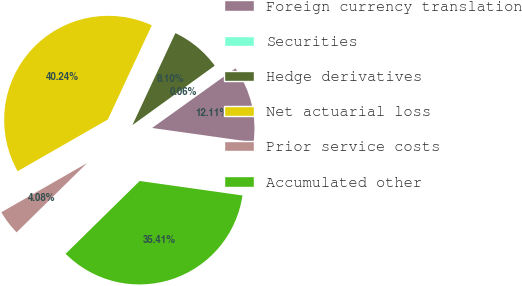Convert chart. <chart><loc_0><loc_0><loc_500><loc_500><pie_chart><fcel>Foreign currency translation<fcel>Securities<fcel>Hedge derivatives<fcel>Net actuarial loss<fcel>Prior service costs<fcel>Accumulated other<nl><fcel>12.11%<fcel>0.06%<fcel>8.1%<fcel>40.24%<fcel>4.08%<fcel>35.41%<nl></chart> 